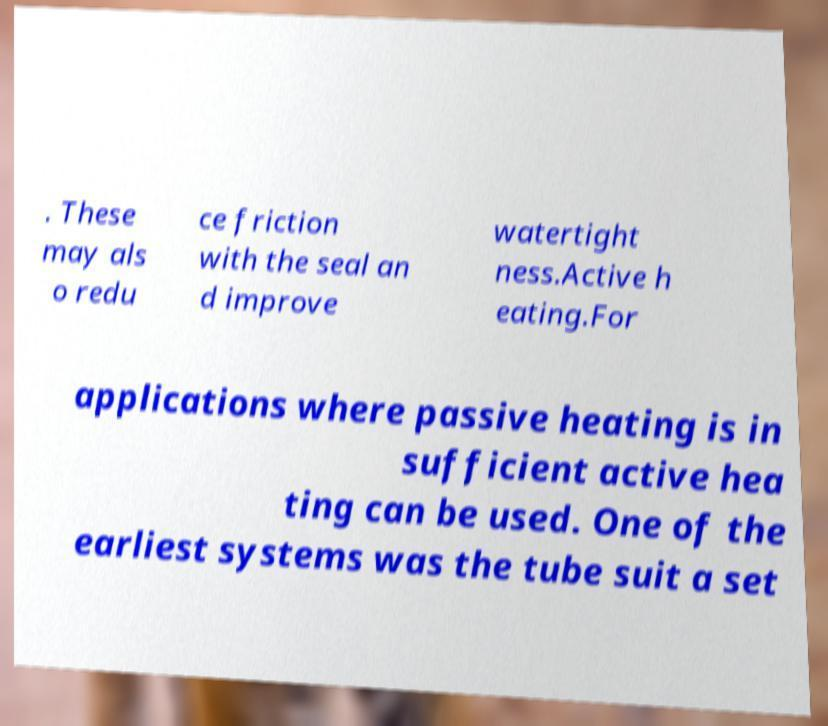I need the written content from this picture converted into text. Can you do that? . These may als o redu ce friction with the seal an d improve watertight ness.Active h eating.For applications where passive heating is in sufficient active hea ting can be used. One of the earliest systems was the tube suit a set 